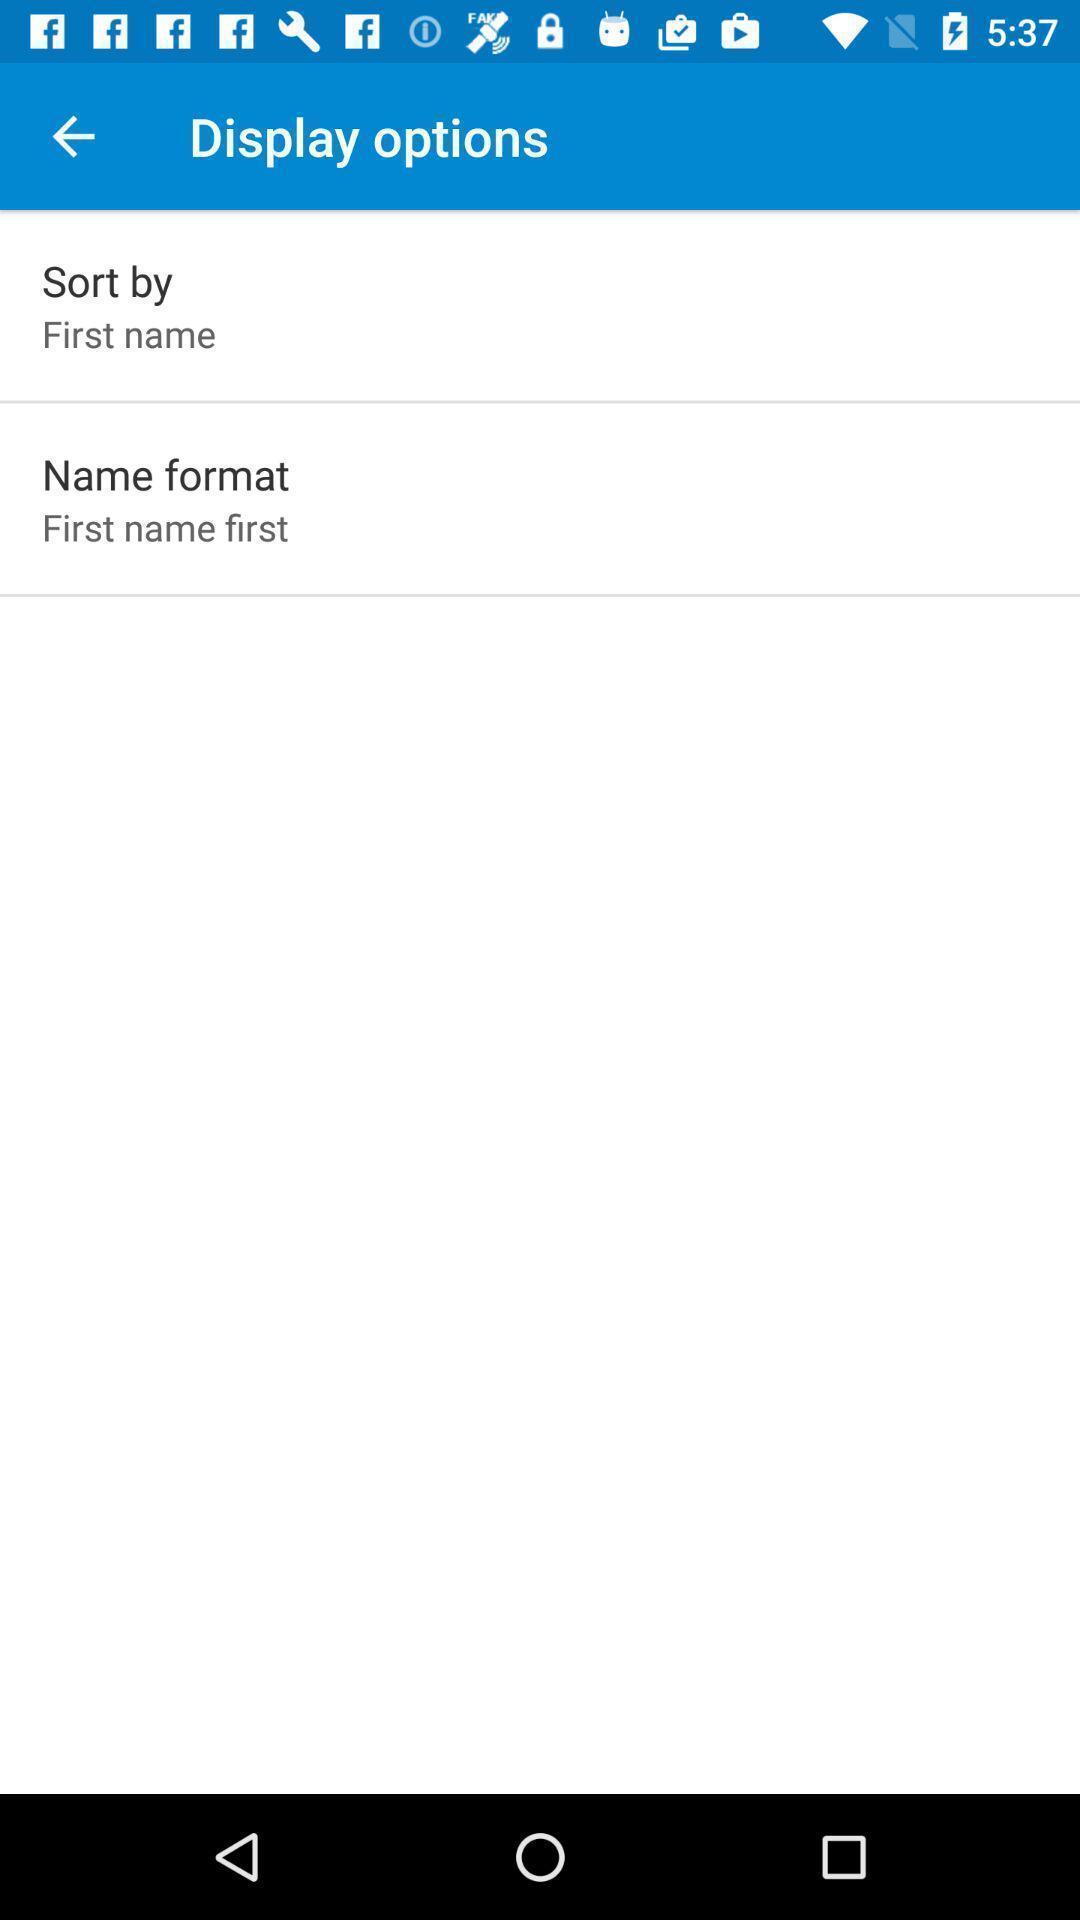Explain what's happening in this screen capture. Screen displaying about display options. 